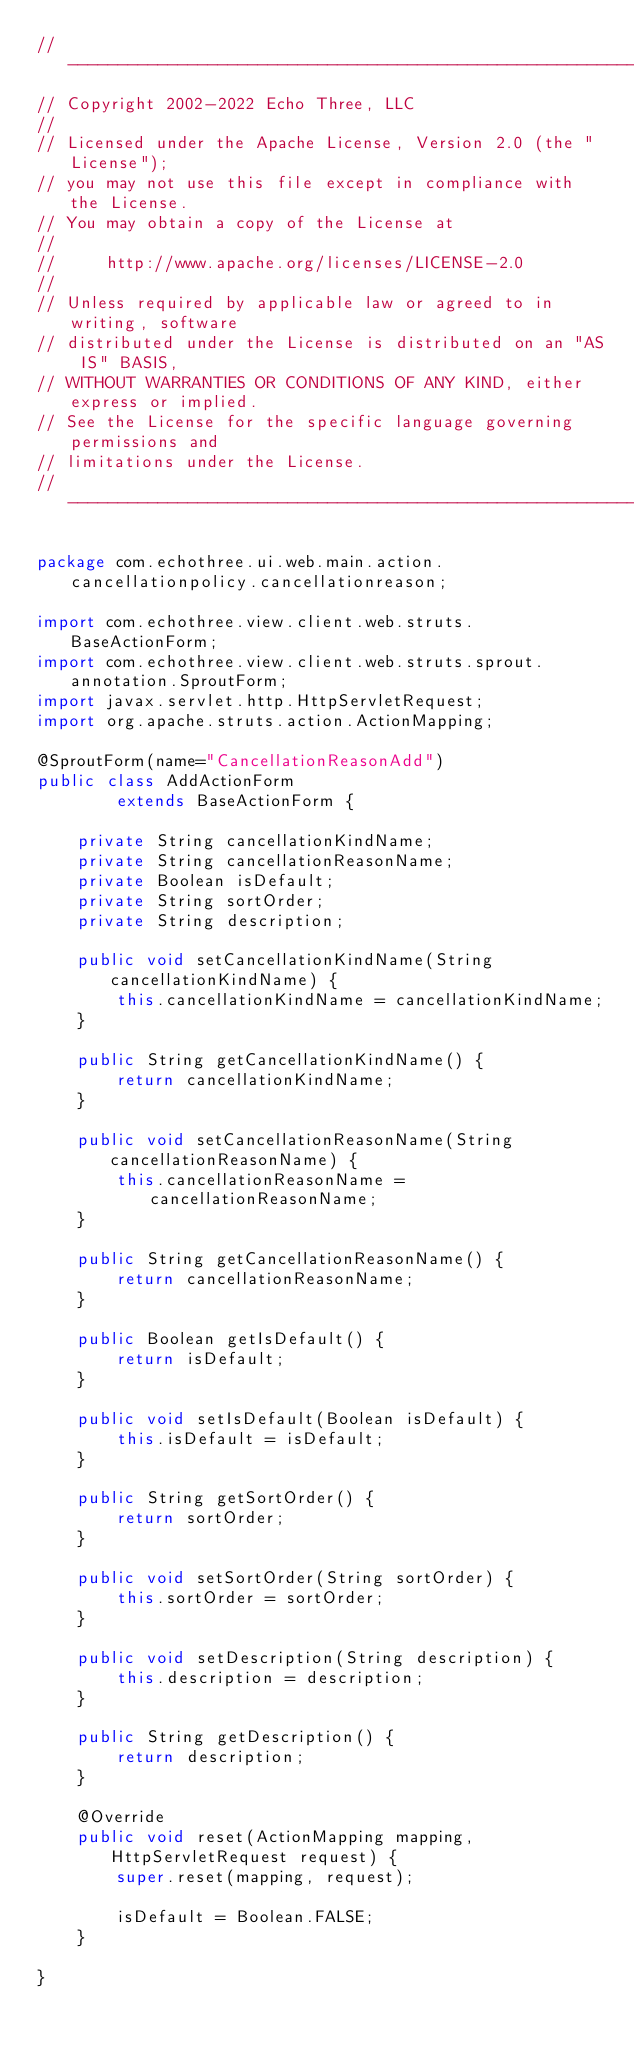<code> <loc_0><loc_0><loc_500><loc_500><_Java_>// --------------------------------------------------------------------------------
// Copyright 2002-2022 Echo Three, LLC
//
// Licensed under the Apache License, Version 2.0 (the "License");
// you may not use this file except in compliance with the License.
// You may obtain a copy of the License at
//
//     http://www.apache.org/licenses/LICENSE-2.0
//
// Unless required by applicable law or agreed to in writing, software
// distributed under the License is distributed on an "AS IS" BASIS,
// WITHOUT WARRANTIES OR CONDITIONS OF ANY KIND, either express or implied.
// See the License for the specific language governing permissions and
// limitations under the License.
// --------------------------------------------------------------------------------

package com.echothree.ui.web.main.action.cancellationpolicy.cancellationreason;

import com.echothree.view.client.web.struts.BaseActionForm;
import com.echothree.view.client.web.struts.sprout.annotation.SproutForm;
import javax.servlet.http.HttpServletRequest;
import org.apache.struts.action.ActionMapping;

@SproutForm(name="CancellationReasonAdd")
public class AddActionForm
        extends BaseActionForm {
    
    private String cancellationKindName;
    private String cancellationReasonName;
    private Boolean isDefault;
    private String sortOrder;
    private String description;
    
    public void setCancellationKindName(String cancellationKindName) {
        this.cancellationKindName = cancellationKindName;
    }
    
    public String getCancellationKindName() {
        return cancellationKindName;
    }
    
    public void setCancellationReasonName(String cancellationReasonName) {
        this.cancellationReasonName = cancellationReasonName;
    }
    
    public String getCancellationReasonName() {
        return cancellationReasonName;
    }
    
    public Boolean getIsDefault() {
        return isDefault;
    }
    
    public void setIsDefault(Boolean isDefault) {
        this.isDefault = isDefault;
    }
    
    public String getSortOrder() {
        return sortOrder;
    }
    
    public void setSortOrder(String sortOrder) {
        this.sortOrder = sortOrder;
    }
    
    public void setDescription(String description) {
        this.description = description;
    }
    
    public String getDescription() {
        return description;
    }
    
    @Override
    public void reset(ActionMapping mapping, HttpServletRequest request) {
        super.reset(mapping, request);
        
        isDefault = Boolean.FALSE;
    }
    
}
</code> 